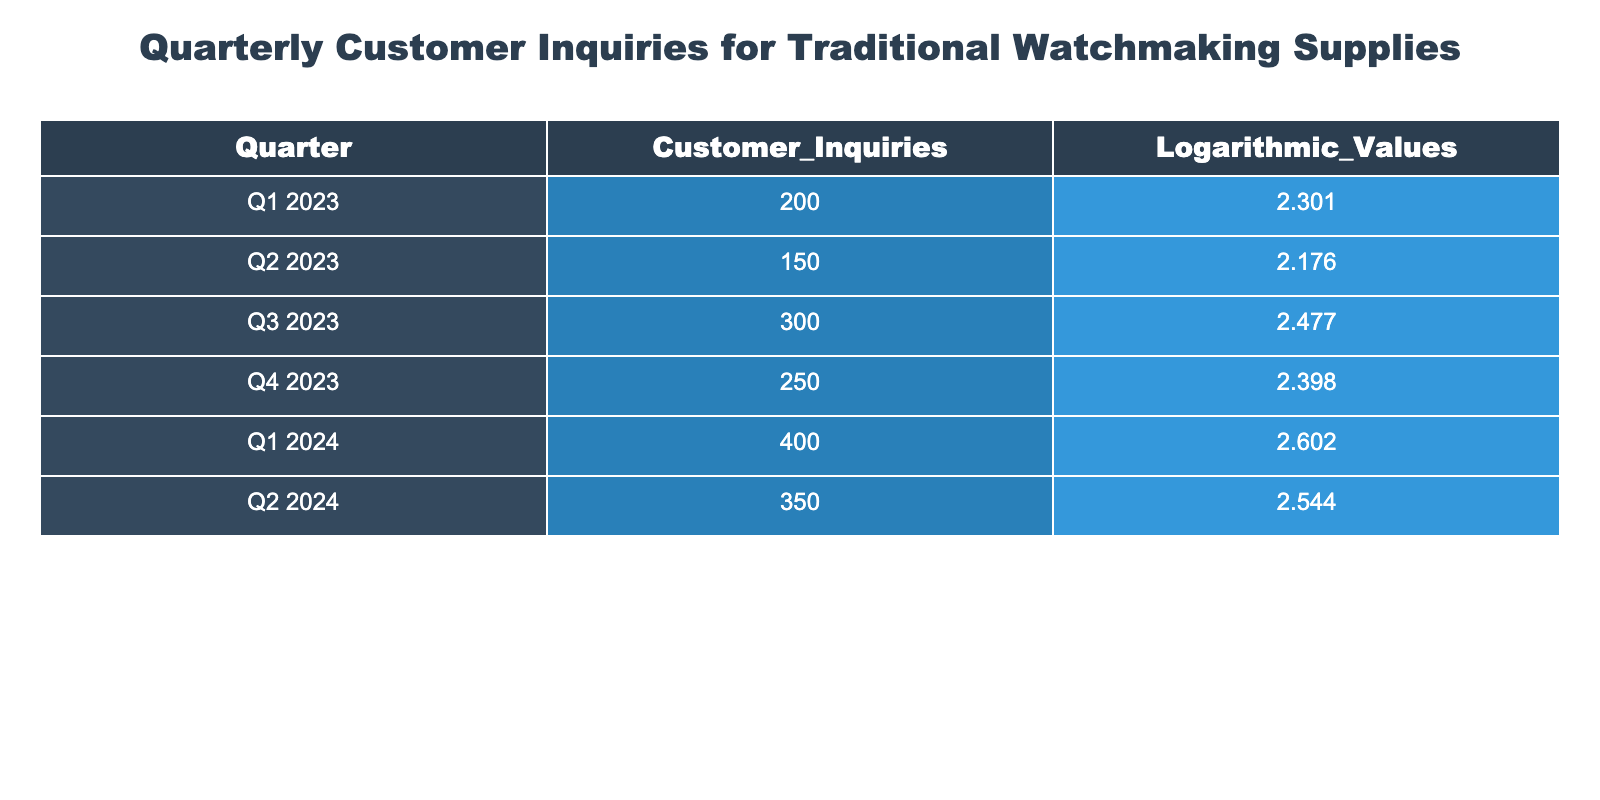What was the total number of customer inquiries in Q3 2023? The table shows that in Q3 2023, the customer inquiries were 300. Hence, the answer is straightforward as it directly retrieves the value from the table.
Answer: 300 What is the logarithmic value for Q1 2024? According to the table, the logarithmic value for Q1 2024 is 2.602, which is directly available in the data provided.
Answer: 2.602 What is the average number of customer inquiries over Q1 2023 and Q1 2024? To find the average of customer inquiries for Q1 2023 and Q1 2024, we first add the inquiries for both quarters: 200 (Q1 2023) + 400 (Q1 2024) = 600. Since we have two quarters, we divide by 2: 600/2 = 300.
Answer: 300 Did the customer inquiries decrease from Q2 2023 to Q3 2023? We can see from the table that the inquiries in Q2 2023 were 150 while in Q3 2023 they were 300. Since 150 is less than 300, it indicates an increase, thus the answer is no.
Answer: No Which quarter had the highest logarithmic value, and what was it? We need to compare the logarithmic values from each quarter: 2.301 (Q1 2023), 2.176 (Q2 2023), 2.477 (Q3 2023), 2.398 (Q4 2023), 2.602 (Q1 2024), and 2.544 (Q2 2024). The highest value is 2.602 for Q1 2024.
Answer: Q1 2024, 2.602 What is the difference in customer inquiries between Q1 2024 and Q2 2024? The inquiries for Q1 2024 are 400 and for Q2 2024 they are 350. The difference can be calculated as 400 - 350 = 50.
Answer: 50 Is the total number of customer inquiries from 2023 greater than the total from the first half of 2024? First, we sum the inquiries for 2023: 200 + 150 + 300 + 250 = 900. Then, for the first half of 2024, we add Q1 and Q2: 400 + 350 = 750. Since 900 is greater than 750, the answer is yes.
Answer: Yes What was the range of the logarithmic values from all quarters? To find the range, we subtract the smallest logarithmic value from the largest. The largest value is 2.602 (Q1 2024) and the smallest is 2.176 (Q2 2023). Thus, the range is 2.602 - 2.176 = 0.426.
Answer: 0.426 How many customer inquiries were there in total for the second half of 2023? From the table, Q3 2023 had 300 inquiries and Q4 2023 had 250 inquiries. Adding these gives: 300 + 250 = 550 inquiries in total for the second half.
Answer: 550 